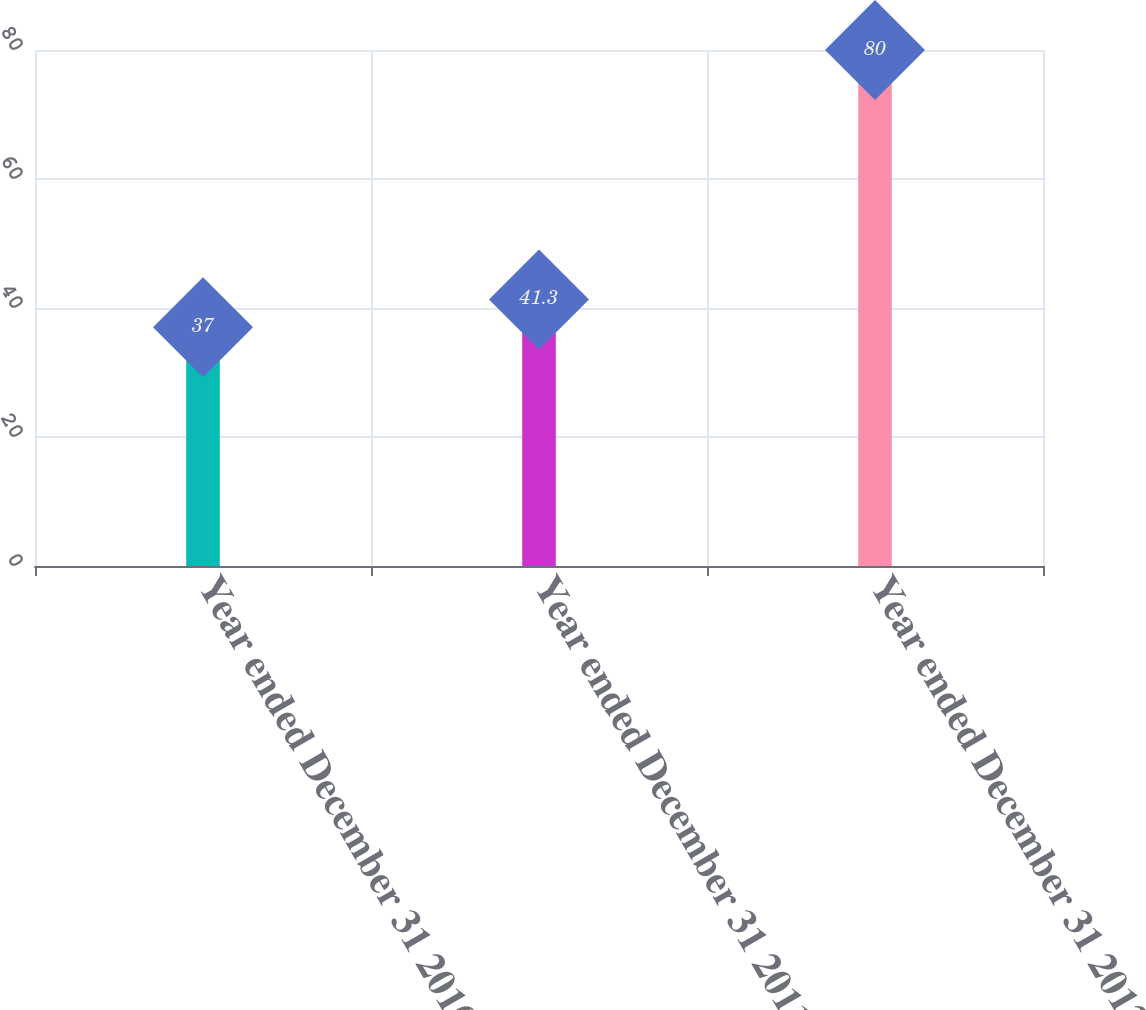<chart> <loc_0><loc_0><loc_500><loc_500><bar_chart><fcel>Year ended December 31 2010<fcel>Year ended December 31 2011<fcel>Year ended December 31 2012<nl><fcel>37<fcel>41.3<fcel>80<nl></chart> 